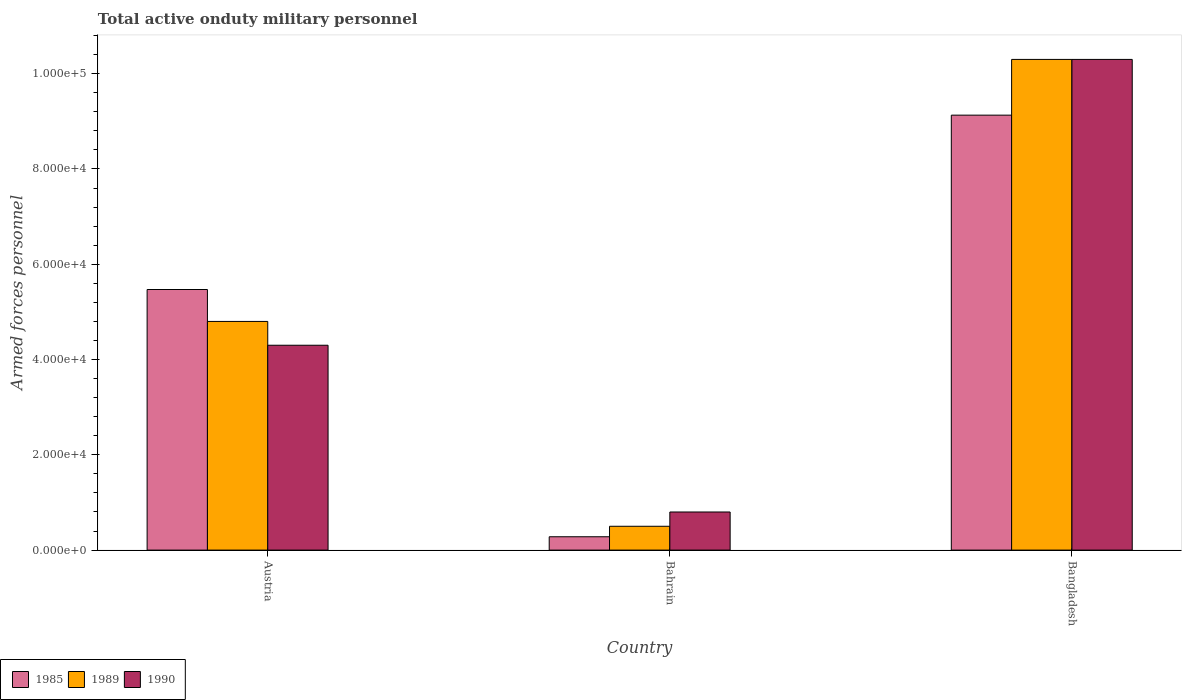How many groups of bars are there?
Your answer should be compact. 3. Are the number of bars per tick equal to the number of legend labels?
Offer a terse response. Yes. How many bars are there on the 1st tick from the left?
Give a very brief answer. 3. How many bars are there on the 2nd tick from the right?
Keep it short and to the point. 3. What is the label of the 2nd group of bars from the left?
Give a very brief answer. Bahrain. What is the number of armed forces personnel in 1985 in Austria?
Make the answer very short. 5.47e+04. Across all countries, what is the maximum number of armed forces personnel in 1989?
Your response must be concise. 1.03e+05. In which country was the number of armed forces personnel in 1990 minimum?
Provide a succinct answer. Bahrain. What is the total number of armed forces personnel in 1985 in the graph?
Ensure brevity in your answer.  1.49e+05. What is the difference between the number of armed forces personnel in 1989 in Austria and that in Bahrain?
Provide a short and direct response. 4.30e+04. What is the difference between the number of armed forces personnel in 1985 in Bangladesh and the number of armed forces personnel in 1990 in Austria?
Your answer should be very brief. 4.83e+04. What is the average number of armed forces personnel in 1985 per country?
Your answer should be compact. 4.96e+04. What is the difference between the number of armed forces personnel of/in 1989 and number of armed forces personnel of/in 1985 in Bangladesh?
Your answer should be very brief. 1.17e+04. What is the ratio of the number of armed forces personnel in 1990 in Austria to that in Bangladesh?
Provide a short and direct response. 0.42. Is the number of armed forces personnel in 1985 in Austria less than that in Bahrain?
Your answer should be compact. No. What is the difference between the highest and the second highest number of armed forces personnel in 1990?
Offer a terse response. 6.00e+04. What is the difference between the highest and the lowest number of armed forces personnel in 1989?
Provide a succinct answer. 9.80e+04. In how many countries, is the number of armed forces personnel in 1989 greater than the average number of armed forces personnel in 1989 taken over all countries?
Your response must be concise. 1. What does the 1st bar from the left in Bahrain represents?
Your answer should be compact. 1985. What does the 2nd bar from the right in Bangladesh represents?
Ensure brevity in your answer.  1989. Is it the case that in every country, the sum of the number of armed forces personnel in 1989 and number of armed forces personnel in 1990 is greater than the number of armed forces personnel in 1985?
Keep it short and to the point. Yes. What is the difference between two consecutive major ticks on the Y-axis?
Offer a terse response. 2.00e+04. Are the values on the major ticks of Y-axis written in scientific E-notation?
Provide a succinct answer. Yes. Does the graph contain grids?
Ensure brevity in your answer.  No. Where does the legend appear in the graph?
Keep it short and to the point. Bottom left. What is the title of the graph?
Make the answer very short. Total active onduty military personnel. Does "2011" appear as one of the legend labels in the graph?
Your answer should be compact. No. What is the label or title of the Y-axis?
Provide a short and direct response. Armed forces personnel. What is the Armed forces personnel of 1985 in Austria?
Your response must be concise. 5.47e+04. What is the Armed forces personnel in 1989 in Austria?
Provide a short and direct response. 4.80e+04. What is the Armed forces personnel in 1990 in Austria?
Your response must be concise. 4.30e+04. What is the Armed forces personnel in 1985 in Bahrain?
Make the answer very short. 2800. What is the Armed forces personnel in 1989 in Bahrain?
Ensure brevity in your answer.  5000. What is the Armed forces personnel in 1990 in Bahrain?
Your answer should be very brief. 8000. What is the Armed forces personnel in 1985 in Bangladesh?
Ensure brevity in your answer.  9.13e+04. What is the Armed forces personnel of 1989 in Bangladesh?
Offer a terse response. 1.03e+05. What is the Armed forces personnel in 1990 in Bangladesh?
Offer a very short reply. 1.03e+05. Across all countries, what is the maximum Armed forces personnel of 1985?
Your answer should be compact. 9.13e+04. Across all countries, what is the maximum Armed forces personnel in 1989?
Make the answer very short. 1.03e+05. Across all countries, what is the maximum Armed forces personnel of 1990?
Your response must be concise. 1.03e+05. Across all countries, what is the minimum Armed forces personnel in 1985?
Ensure brevity in your answer.  2800. Across all countries, what is the minimum Armed forces personnel of 1989?
Provide a succinct answer. 5000. Across all countries, what is the minimum Armed forces personnel of 1990?
Provide a succinct answer. 8000. What is the total Armed forces personnel in 1985 in the graph?
Offer a very short reply. 1.49e+05. What is the total Armed forces personnel in 1989 in the graph?
Provide a short and direct response. 1.56e+05. What is the total Armed forces personnel of 1990 in the graph?
Offer a very short reply. 1.54e+05. What is the difference between the Armed forces personnel in 1985 in Austria and that in Bahrain?
Your answer should be compact. 5.19e+04. What is the difference between the Armed forces personnel in 1989 in Austria and that in Bahrain?
Keep it short and to the point. 4.30e+04. What is the difference between the Armed forces personnel of 1990 in Austria and that in Bahrain?
Offer a very short reply. 3.50e+04. What is the difference between the Armed forces personnel in 1985 in Austria and that in Bangladesh?
Provide a short and direct response. -3.66e+04. What is the difference between the Armed forces personnel in 1989 in Austria and that in Bangladesh?
Ensure brevity in your answer.  -5.50e+04. What is the difference between the Armed forces personnel of 1990 in Austria and that in Bangladesh?
Ensure brevity in your answer.  -6.00e+04. What is the difference between the Armed forces personnel of 1985 in Bahrain and that in Bangladesh?
Provide a succinct answer. -8.85e+04. What is the difference between the Armed forces personnel of 1989 in Bahrain and that in Bangladesh?
Provide a succinct answer. -9.80e+04. What is the difference between the Armed forces personnel in 1990 in Bahrain and that in Bangladesh?
Offer a very short reply. -9.50e+04. What is the difference between the Armed forces personnel in 1985 in Austria and the Armed forces personnel in 1989 in Bahrain?
Your response must be concise. 4.97e+04. What is the difference between the Armed forces personnel of 1985 in Austria and the Armed forces personnel of 1990 in Bahrain?
Provide a short and direct response. 4.67e+04. What is the difference between the Armed forces personnel in 1985 in Austria and the Armed forces personnel in 1989 in Bangladesh?
Ensure brevity in your answer.  -4.83e+04. What is the difference between the Armed forces personnel in 1985 in Austria and the Armed forces personnel in 1990 in Bangladesh?
Ensure brevity in your answer.  -4.83e+04. What is the difference between the Armed forces personnel of 1989 in Austria and the Armed forces personnel of 1990 in Bangladesh?
Keep it short and to the point. -5.50e+04. What is the difference between the Armed forces personnel of 1985 in Bahrain and the Armed forces personnel of 1989 in Bangladesh?
Make the answer very short. -1.00e+05. What is the difference between the Armed forces personnel in 1985 in Bahrain and the Armed forces personnel in 1990 in Bangladesh?
Keep it short and to the point. -1.00e+05. What is the difference between the Armed forces personnel of 1989 in Bahrain and the Armed forces personnel of 1990 in Bangladesh?
Provide a succinct answer. -9.80e+04. What is the average Armed forces personnel of 1985 per country?
Give a very brief answer. 4.96e+04. What is the average Armed forces personnel in 1989 per country?
Provide a short and direct response. 5.20e+04. What is the average Armed forces personnel of 1990 per country?
Your response must be concise. 5.13e+04. What is the difference between the Armed forces personnel of 1985 and Armed forces personnel of 1989 in Austria?
Offer a terse response. 6700. What is the difference between the Armed forces personnel of 1985 and Armed forces personnel of 1990 in Austria?
Ensure brevity in your answer.  1.17e+04. What is the difference between the Armed forces personnel in 1989 and Armed forces personnel in 1990 in Austria?
Your answer should be very brief. 5000. What is the difference between the Armed forces personnel of 1985 and Armed forces personnel of 1989 in Bahrain?
Offer a very short reply. -2200. What is the difference between the Armed forces personnel in 1985 and Armed forces personnel in 1990 in Bahrain?
Your answer should be compact. -5200. What is the difference between the Armed forces personnel in 1989 and Armed forces personnel in 1990 in Bahrain?
Provide a short and direct response. -3000. What is the difference between the Armed forces personnel in 1985 and Armed forces personnel in 1989 in Bangladesh?
Your response must be concise. -1.17e+04. What is the difference between the Armed forces personnel of 1985 and Armed forces personnel of 1990 in Bangladesh?
Make the answer very short. -1.17e+04. What is the ratio of the Armed forces personnel in 1985 in Austria to that in Bahrain?
Ensure brevity in your answer.  19.54. What is the ratio of the Armed forces personnel in 1990 in Austria to that in Bahrain?
Give a very brief answer. 5.38. What is the ratio of the Armed forces personnel of 1985 in Austria to that in Bangladesh?
Your answer should be very brief. 0.6. What is the ratio of the Armed forces personnel of 1989 in Austria to that in Bangladesh?
Your response must be concise. 0.47. What is the ratio of the Armed forces personnel of 1990 in Austria to that in Bangladesh?
Ensure brevity in your answer.  0.42. What is the ratio of the Armed forces personnel of 1985 in Bahrain to that in Bangladesh?
Keep it short and to the point. 0.03. What is the ratio of the Armed forces personnel in 1989 in Bahrain to that in Bangladesh?
Your answer should be compact. 0.05. What is the ratio of the Armed forces personnel of 1990 in Bahrain to that in Bangladesh?
Provide a succinct answer. 0.08. What is the difference between the highest and the second highest Armed forces personnel in 1985?
Your answer should be very brief. 3.66e+04. What is the difference between the highest and the second highest Armed forces personnel of 1989?
Keep it short and to the point. 5.50e+04. What is the difference between the highest and the lowest Armed forces personnel of 1985?
Offer a very short reply. 8.85e+04. What is the difference between the highest and the lowest Armed forces personnel of 1989?
Make the answer very short. 9.80e+04. What is the difference between the highest and the lowest Armed forces personnel in 1990?
Provide a succinct answer. 9.50e+04. 